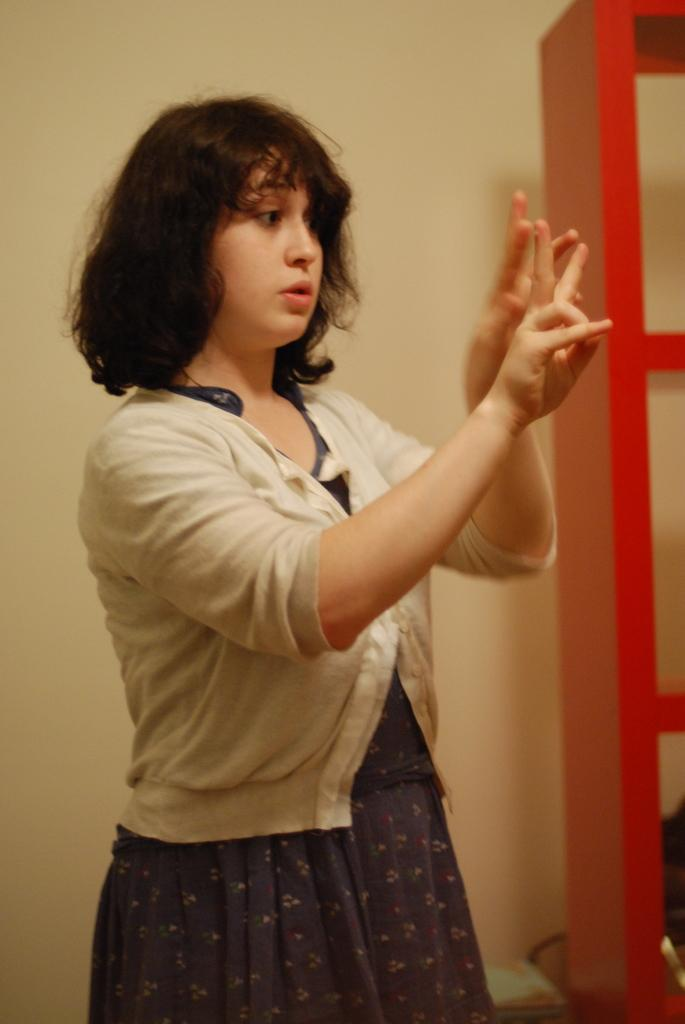What is the main subject of the image? There is a woman standing in the image. What can be seen on the right side of the image? There are racks on the right side of the image. What is visible at the top of the image? There is a wall visible at the top of the image. What type of music is the boy playing on the wall in the image? There is no boy or music present in the image; it only features a woman standing and racks on the right side. 